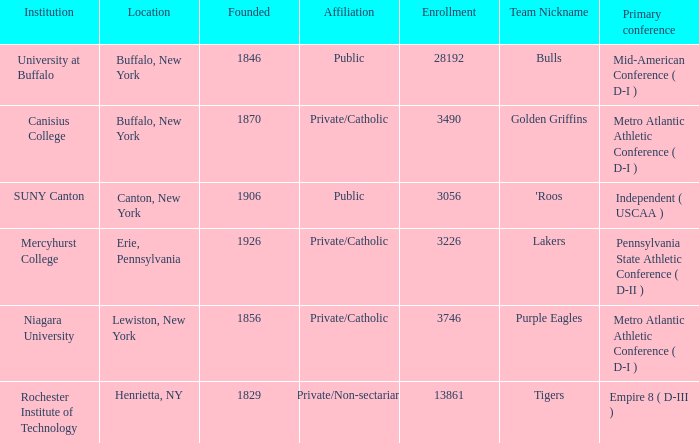In canton, new york, what kind of educational establishment can be found? Public. 